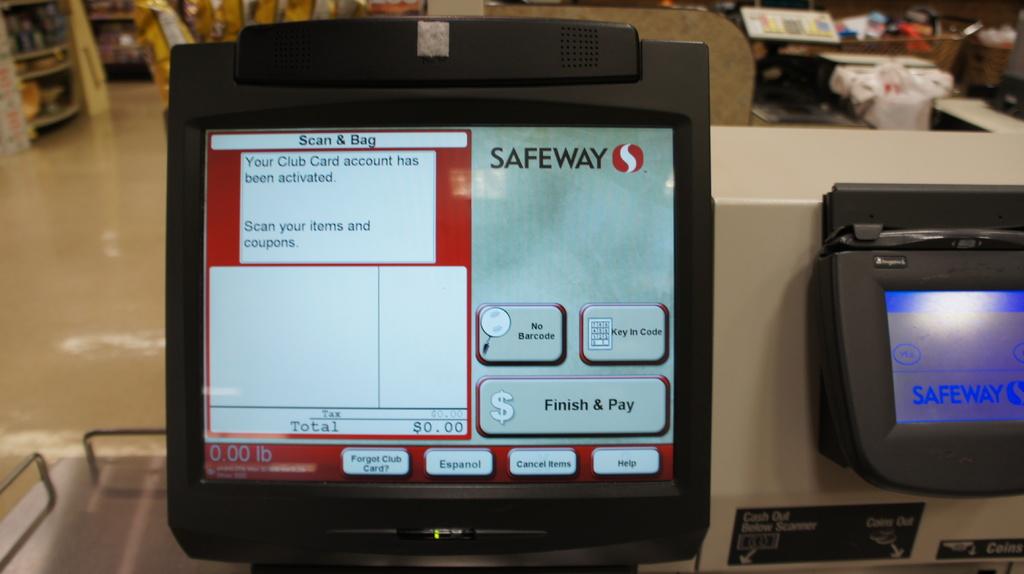Which supermarket is this for?
Your response must be concise. Safeway. Where is the button do you push to finis?
Provide a succinct answer. Bottom right. 